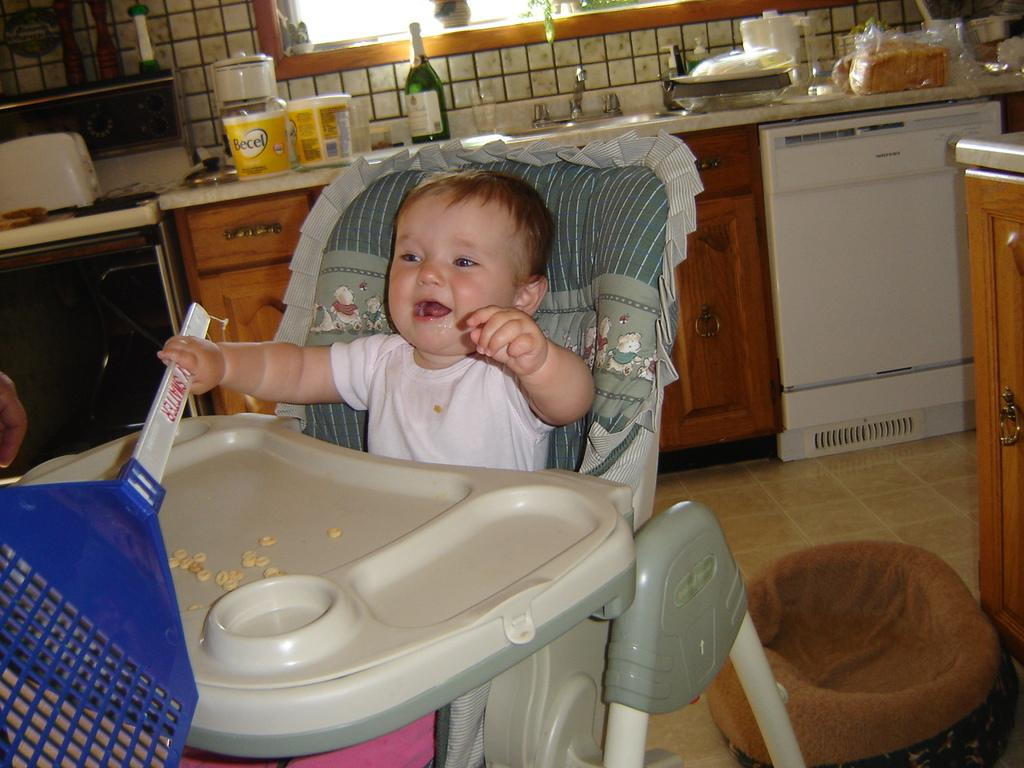What is the kid doing in the image? The kid is sitting on a stroller and holding a bat in his hand. What can be seen in the background of the image? There are cupboards, a grinder, a wine bottle, a sink, bread, a jug, and a window in the background. What is the surface the stroller is placed on? The floor is visible in the image. Where is the key located in the image? There is no key present in the image. What type of drink is being prepared in the background using the grinder and jug? The image does not show any drink preparation, and there is no mention of eggnog or any other specific drink. 